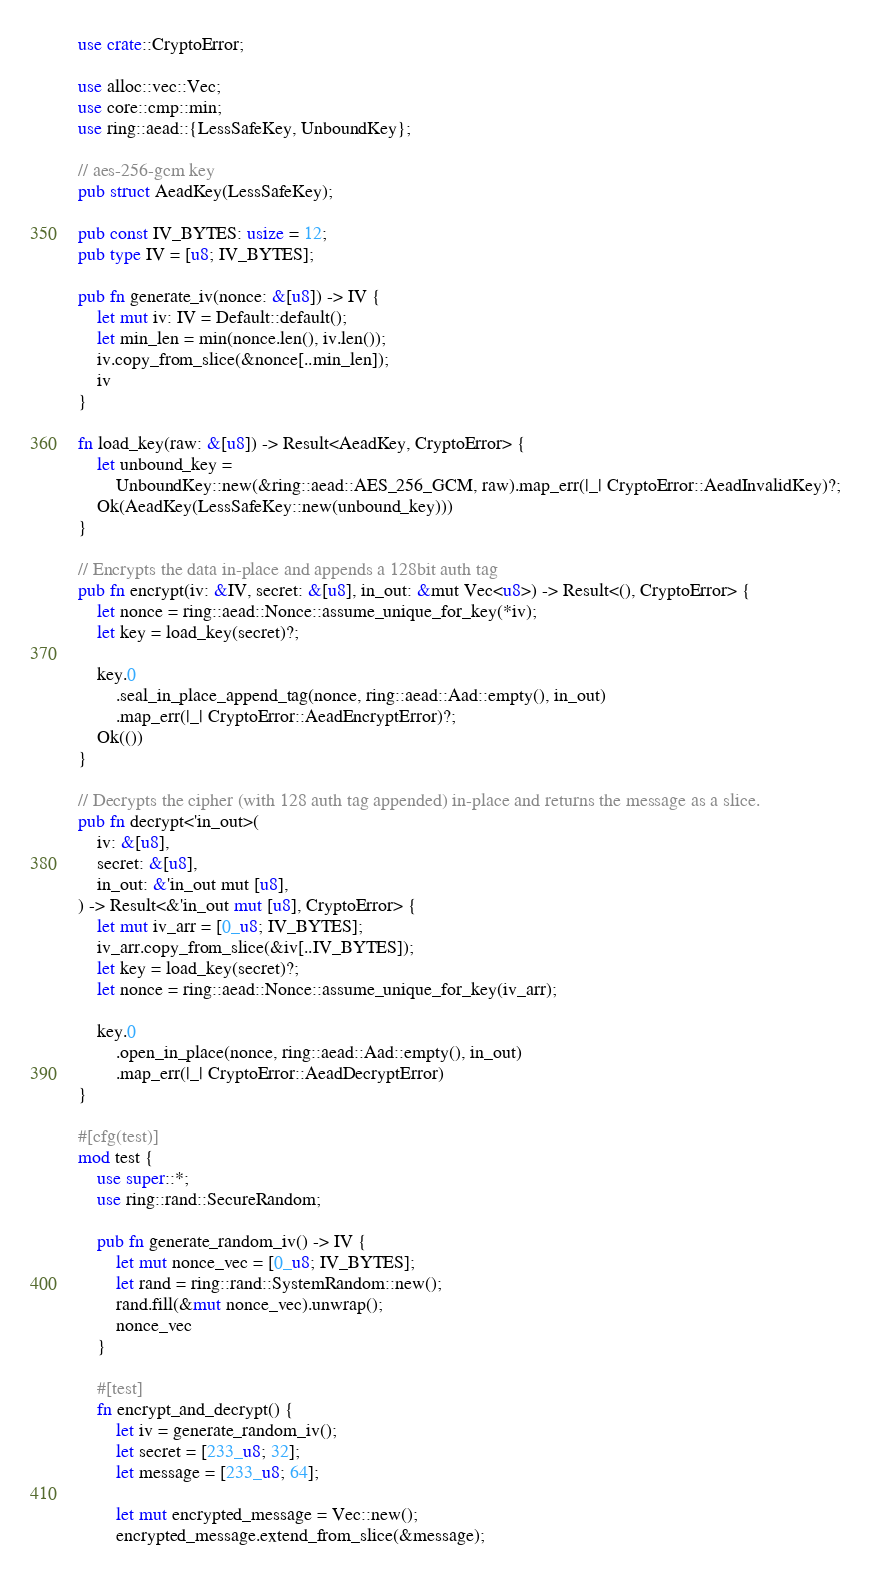<code> <loc_0><loc_0><loc_500><loc_500><_Rust_>use crate::CryptoError;

use alloc::vec::Vec;
use core::cmp::min;
use ring::aead::{LessSafeKey, UnboundKey};

// aes-256-gcm key
pub struct AeadKey(LessSafeKey);

pub const IV_BYTES: usize = 12;
pub type IV = [u8; IV_BYTES];

pub fn generate_iv(nonce: &[u8]) -> IV {
    let mut iv: IV = Default::default();
    let min_len = min(nonce.len(), iv.len());
    iv.copy_from_slice(&nonce[..min_len]);
    iv
}

fn load_key(raw: &[u8]) -> Result<AeadKey, CryptoError> {
    let unbound_key =
        UnboundKey::new(&ring::aead::AES_256_GCM, raw).map_err(|_| CryptoError::AeadInvalidKey)?;
    Ok(AeadKey(LessSafeKey::new(unbound_key)))
}

// Encrypts the data in-place and appends a 128bit auth tag
pub fn encrypt(iv: &IV, secret: &[u8], in_out: &mut Vec<u8>) -> Result<(), CryptoError> {
    let nonce = ring::aead::Nonce::assume_unique_for_key(*iv);
    let key = load_key(secret)?;

    key.0
        .seal_in_place_append_tag(nonce, ring::aead::Aad::empty(), in_out)
        .map_err(|_| CryptoError::AeadEncryptError)?;
    Ok(())
}

// Decrypts the cipher (with 128 auth tag appended) in-place and returns the message as a slice.
pub fn decrypt<'in_out>(
    iv: &[u8],
    secret: &[u8],
    in_out: &'in_out mut [u8],
) -> Result<&'in_out mut [u8], CryptoError> {
    let mut iv_arr = [0_u8; IV_BYTES];
    iv_arr.copy_from_slice(&iv[..IV_BYTES]);
    let key = load_key(secret)?;
    let nonce = ring::aead::Nonce::assume_unique_for_key(iv_arr);

    key.0
        .open_in_place(nonce, ring::aead::Aad::empty(), in_out)
        .map_err(|_| CryptoError::AeadDecryptError)
}

#[cfg(test)]
mod test {
    use super::*;
    use ring::rand::SecureRandom;

    pub fn generate_random_iv() -> IV {
        let mut nonce_vec = [0_u8; IV_BYTES];
        let rand = ring::rand::SystemRandom::new();
        rand.fill(&mut nonce_vec).unwrap();
        nonce_vec
    }

    #[test]
    fn encrypt_and_decrypt() {
        let iv = generate_random_iv();
        let secret = [233_u8; 32];
        let message = [233_u8; 64];

        let mut encrypted_message = Vec::new();
        encrypted_message.extend_from_slice(&message);
</code> 